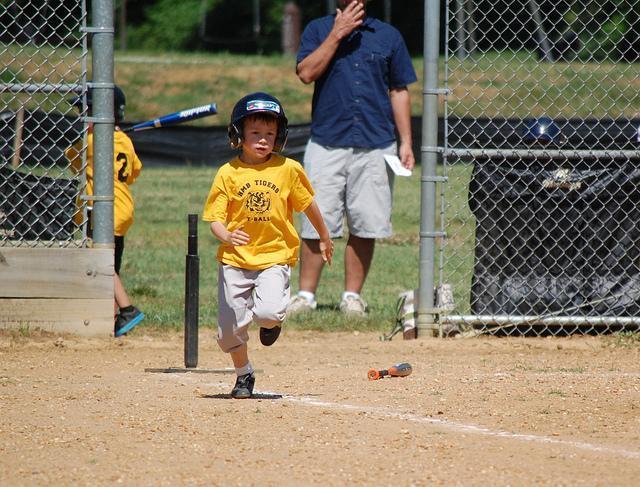How many people are in the photo?
Give a very brief answer. 3. 